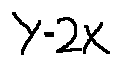Convert formula to latex. <formula><loc_0><loc_0><loc_500><loc_500>y = 2 x</formula> 